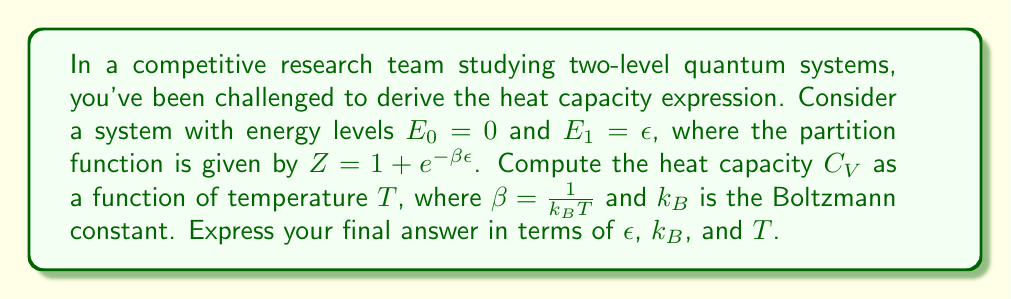Solve this math problem. Let's approach this step-by-step:

1) The average energy of the system is given by:
   $$\langle E \rangle = -\frac{\partial \ln Z}{\partial \beta}$$

2) First, let's calculate $\ln Z$:
   $$\ln Z = \ln(1 + e^{-\beta\epsilon})$$

3) Now, let's find $\langle E \rangle$:
   $$\langle E \rangle = -\frac{\partial}{\partial \beta}\ln(1 + e^{-\beta\epsilon}) = \frac{\epsilon e^{-\beta\epsilon}}{1 + e^{-\beta\epsilon}}$$

4) The heat capacity is defined as:
   $$C_V = \frac{\partial \langle E \rangle}{\partial T} = \frac{\partial \langle E \rangle}{\partial \beta} \cdot \frac{\partial \beta}{\partial T}$$

5) We know that $\beta = \frac{1}{k_B T}$, so $\frac{\partial \beta}{\partial T} = -\frac{1}{k_B T^2}$

6) Now, let's calculate $\frac{\partial \langle E \rangle}{\partial \beta}$:
   $$\frac{\partial \langle E \rangle}{\partial \beta} = \epsilon^2 \frac{e^{-\beta\epsilon}}{(1 + e^{-\beta\epsilon})^2}$$

7) Putting it all together:
   $$C_V = -\frac{1}{k_B T^2} \cdot \epsilon^2 \frac{e^{-\beta\epsilon}}{(1 + e^{-\beta\epsilon})^2}$$

8) Substituting $\beta = \frac{1}{k_B T}$:
   $$C_V = k_B \left(\frac{\epsilon}{k_B T}\right)^2 \frac{e^{\epsilon/(k_B T)}}{(1 + e^{\epsilon/(k_B T)})^2}$$
Answer: $C_V = k_B \left(\frac{\epsilon}{k_B T}\right)^2 \frac{e^{\epsilon/(k_B T)}}{(1 + e^{\epsilon/(k_B T)})^2}$ 